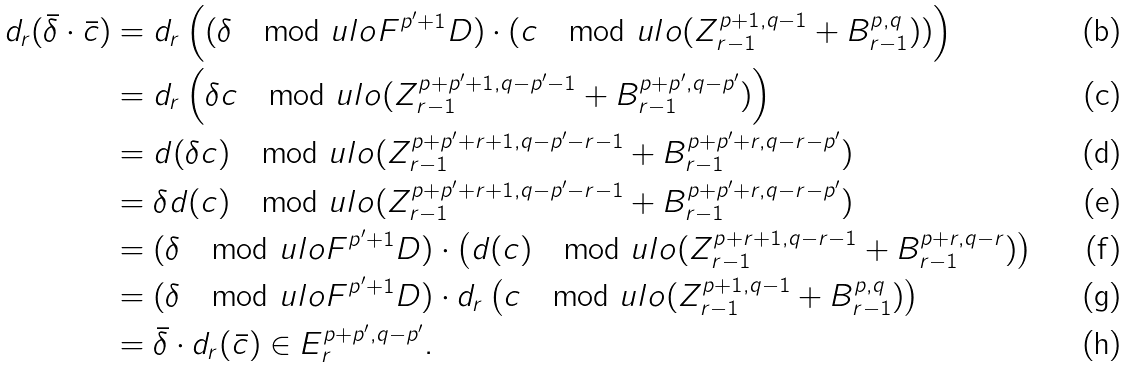Convert formula to latex. <formula><loc_0><loc_0><loc_500><loc_500>d _ { r } ( \bar { \delta } \cdot \bar { c } ) & = d _ { r } \left ( ( \delta \mod u l o F ^ { p ^ { \prime } + 1 } D ) \cdot ( c \mod u l o ( Z ^ { p + 1 , q - 1 } _ { r - 1 } + B ^ { p , q } _ { r - 1 } ) ) \right ) \\ & = d _ { r } \left ( \delta c \mod u l o ( Z ^ { p + p ^ { \prime } + 1 , q - p ^ { \prime } - 1 } _ { r - 1 } + B ^ { p + p ^ { \prime } , q - p ^ { \prime } } _ { r - 1 } ) \right ) \\ & = d ( \delta c ) \mod u l o ( Z ^ { p + p ^ { \prime } + r + 1 , q - p ^ { \prime } - r - 1 } _ { r - 1 } + B ^ { p + p ^ { \prime } + r , q - r - p ^ { \prime } } _ { r - 1 } ) \\ & = \delta d ( c ) \mod u l o ( Z ^ { p + p ^ { \prime } + r + 1 , q - p ^ { \prime } - r - 1 } _ { r - 1 } + B ^ { p + p ^ { \prime } + r , q - r - p ^ { \prime } } _ { r - 1 } ) \\ & = ( \delta \mod u l o F ^ { p ^ { \prime } + 1 } D ) \cdot \left ( d ( c ) \mod u l o ( Z ^ { p + r + 1 , q - r - 1 } _ { r - 1 } + B ^ { p + r , q - r } _ { r - 1 } ) \right ) \\ & = ( \delta \mod u l o F ^ { p ^ { \prime } + 1 } D ) \cdot d _ { r } \left ( c \mod u l o ( Z ^ { p + 1 , q - 1 } _ { r - 1 } + B ^ { p , q } _ { r - 1 } ) \right ) \\ & = \bar { \delta } \cdot d _ { r } ( \bar { c } ) \in E ^ { p + p ^ { \prime } , q - p ^ { \prime } } _ { r } .</formula> 